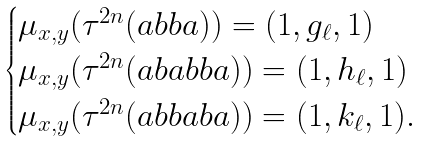<formula> <loc_0><loc_0><loc_500><loc_500>\begin{cases} \mu _ { x , y } ( \tau ^ { 2 n } ( a b b a ) ) = ( 1 , g _ { \ell } , 1 ) \\ \mu _ { x , y } ( \tau ^ { 2 n } ( a b a b b a ) ) = ( 1 , h _ { \ell } , 1 ) \\ \mu _ { x , y } ( \tau ^ { 2 n } ( a b b a b a ) ) = ( 1 , k _ { \ell } , 1 ) . \end{cases}</formula> 